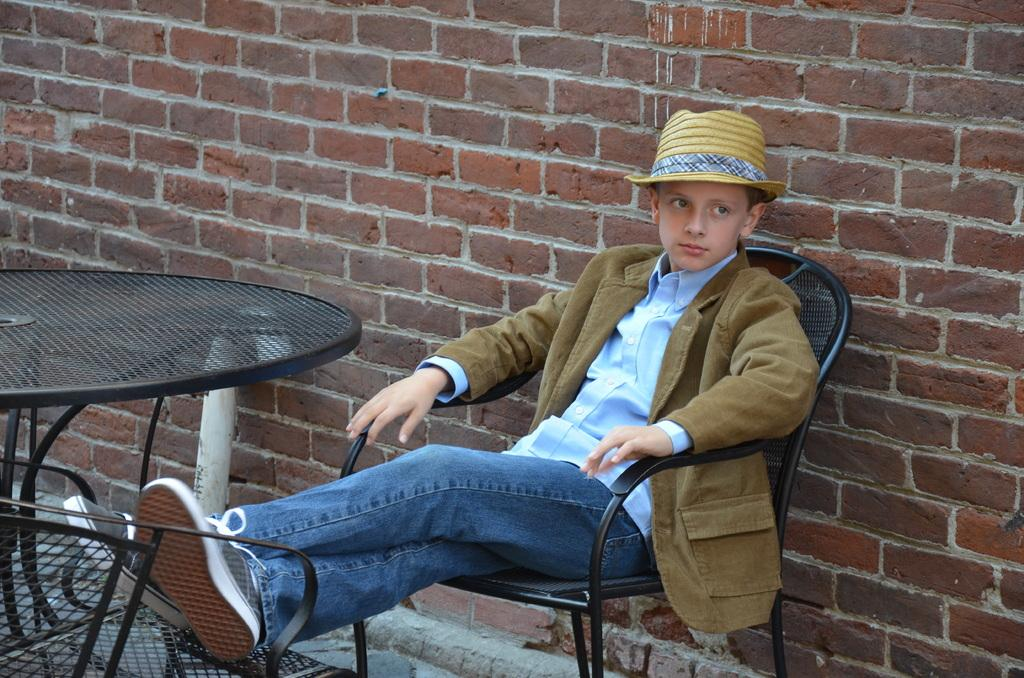Who is the main subject in the image? There is a boy in the image. What is the boy doing in the image? The boy is sitting on a chair. What other furniture is present in the image? There is a table in the image. What can be seen in the background of the image? There is a brick wall in the background of the image. What type of feather can be seen floating near the boy in the image? There is no feather present in the image; it only features a boy sitting on a chair, a table, and a brick wall in the background. 